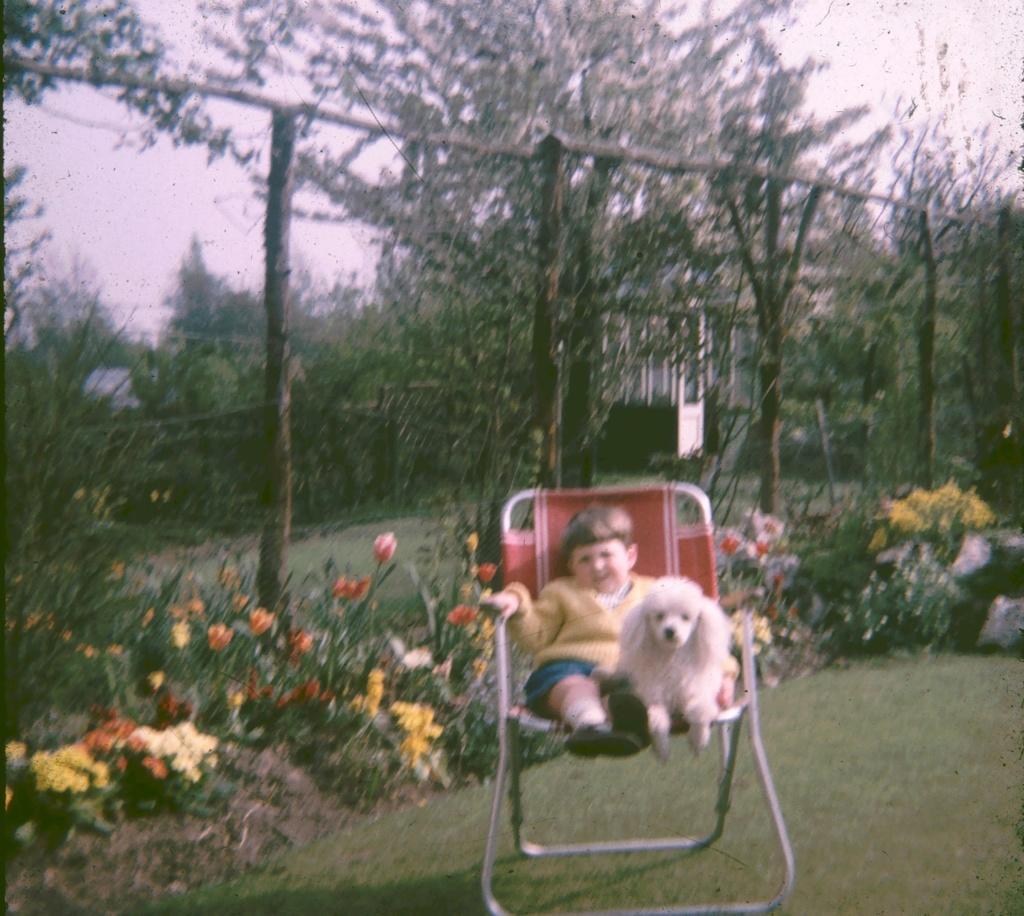In one or two sentences, can you explain what this image depicts? In the image there is a boy sitting on chair and holding a dog. In background there are some plants with flowers and trees and sky on top. 